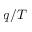Convert formula to latex. <formula><loc_0><loc_0><loc_500><loc_500>q / T</formula> 